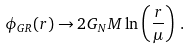Convert formula to latex. <formula><loc_0><loc_0><loc_500><loc_500>\phi _ { G R } ( r ) \rightarrow 2 G _ { N } M \ln \left ( \frac { r } { \mu } \right ) \, .</formula> 